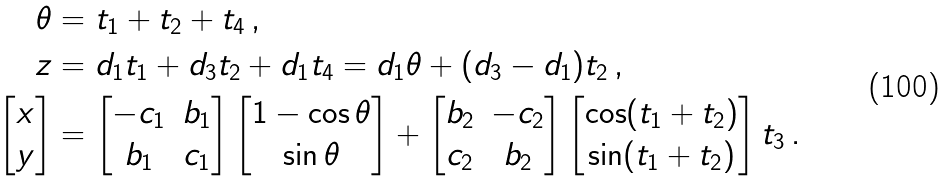<formula> <loc_0><loc_0><loc_500><loc_500>\theta & = t _ { 1 } + t _ { 2 } + t _ { 4 } \, , \\ z & = d _ { 1 } t _ { 1 } + d _ { 3 } t _ { 2 } + d _ { 1 } t _ { 4 } = d _ { 1 } \theta + ( d _ { 3 } - d _ { 1 } ) t _ { 2 } \, , \\ \begin{bmatrix} x \\ y \end{bmatrix} & = \begin{bmatrix} - c _ { 1 } & b _ { 1 } \\ b _ { 1 } & c _ { 1 } \end{bmatrix} \begin{bmatrix} 1 - \cos \theta \\ \sin \theta \end{bmatrix} + \begin{bmatrix} b _ { 2 } & - c _ { 2 } \\ c _ { 2 } & b _ { 2 } \end{bmatrix} \begin{bmatrix} \cos ( t _ { 1 } + t _ { 2 } ) \\ \sin ( t _ { 1 } + t _ { 2 } ) \end{bmatrix} t _ { 3 } \, .</formula> 